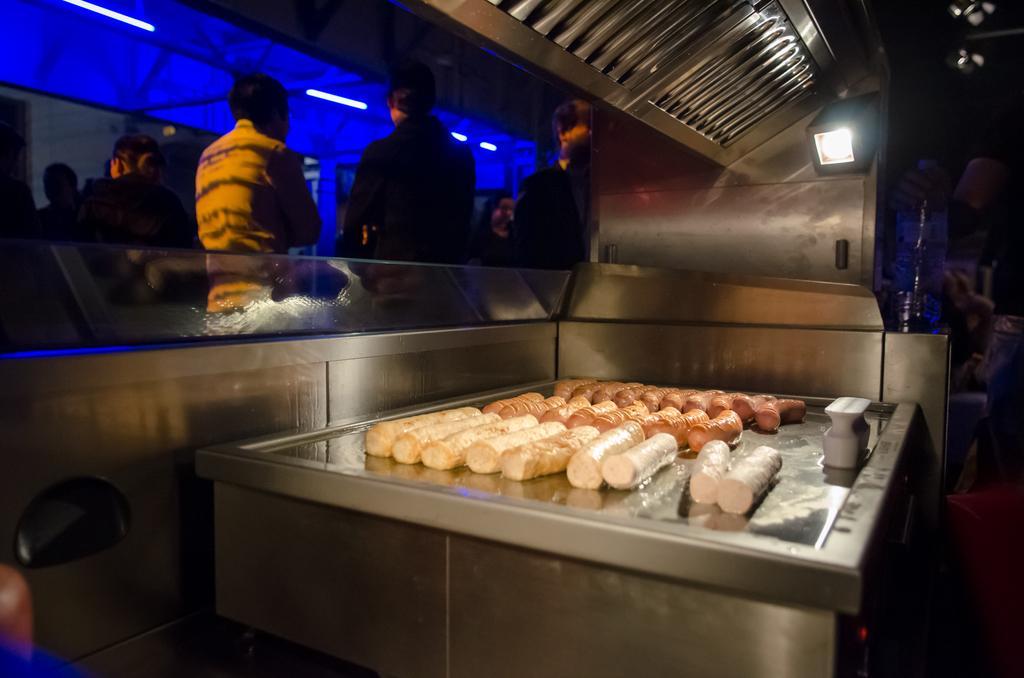In one or two sentences, can you explain what this image depicts? In this image we can see the food items on the top of an object. We can also see the glass barrier and behind the barrier we can see some people standing. We can also see the lights and this image is taken during night time. On the left there is some person holding the mirror. 